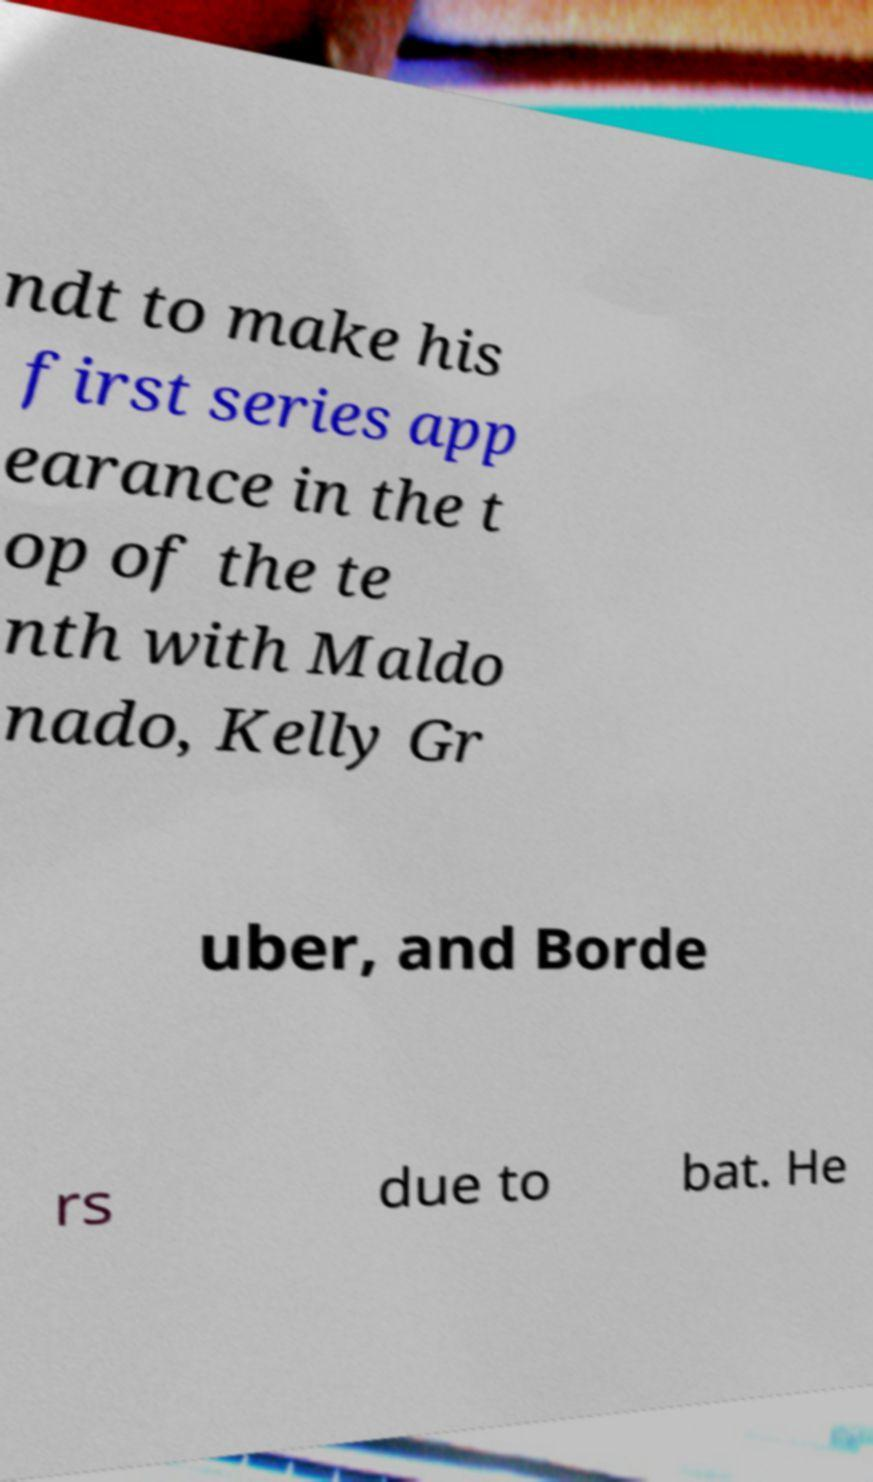There's text embedded in this image that I need extracted. Can you transcribe it verbatim? ndt to make his first series app earance in the t op of the te nth with Maldo nado, Kelly Gr uber, and Borde rs due to bat. He 